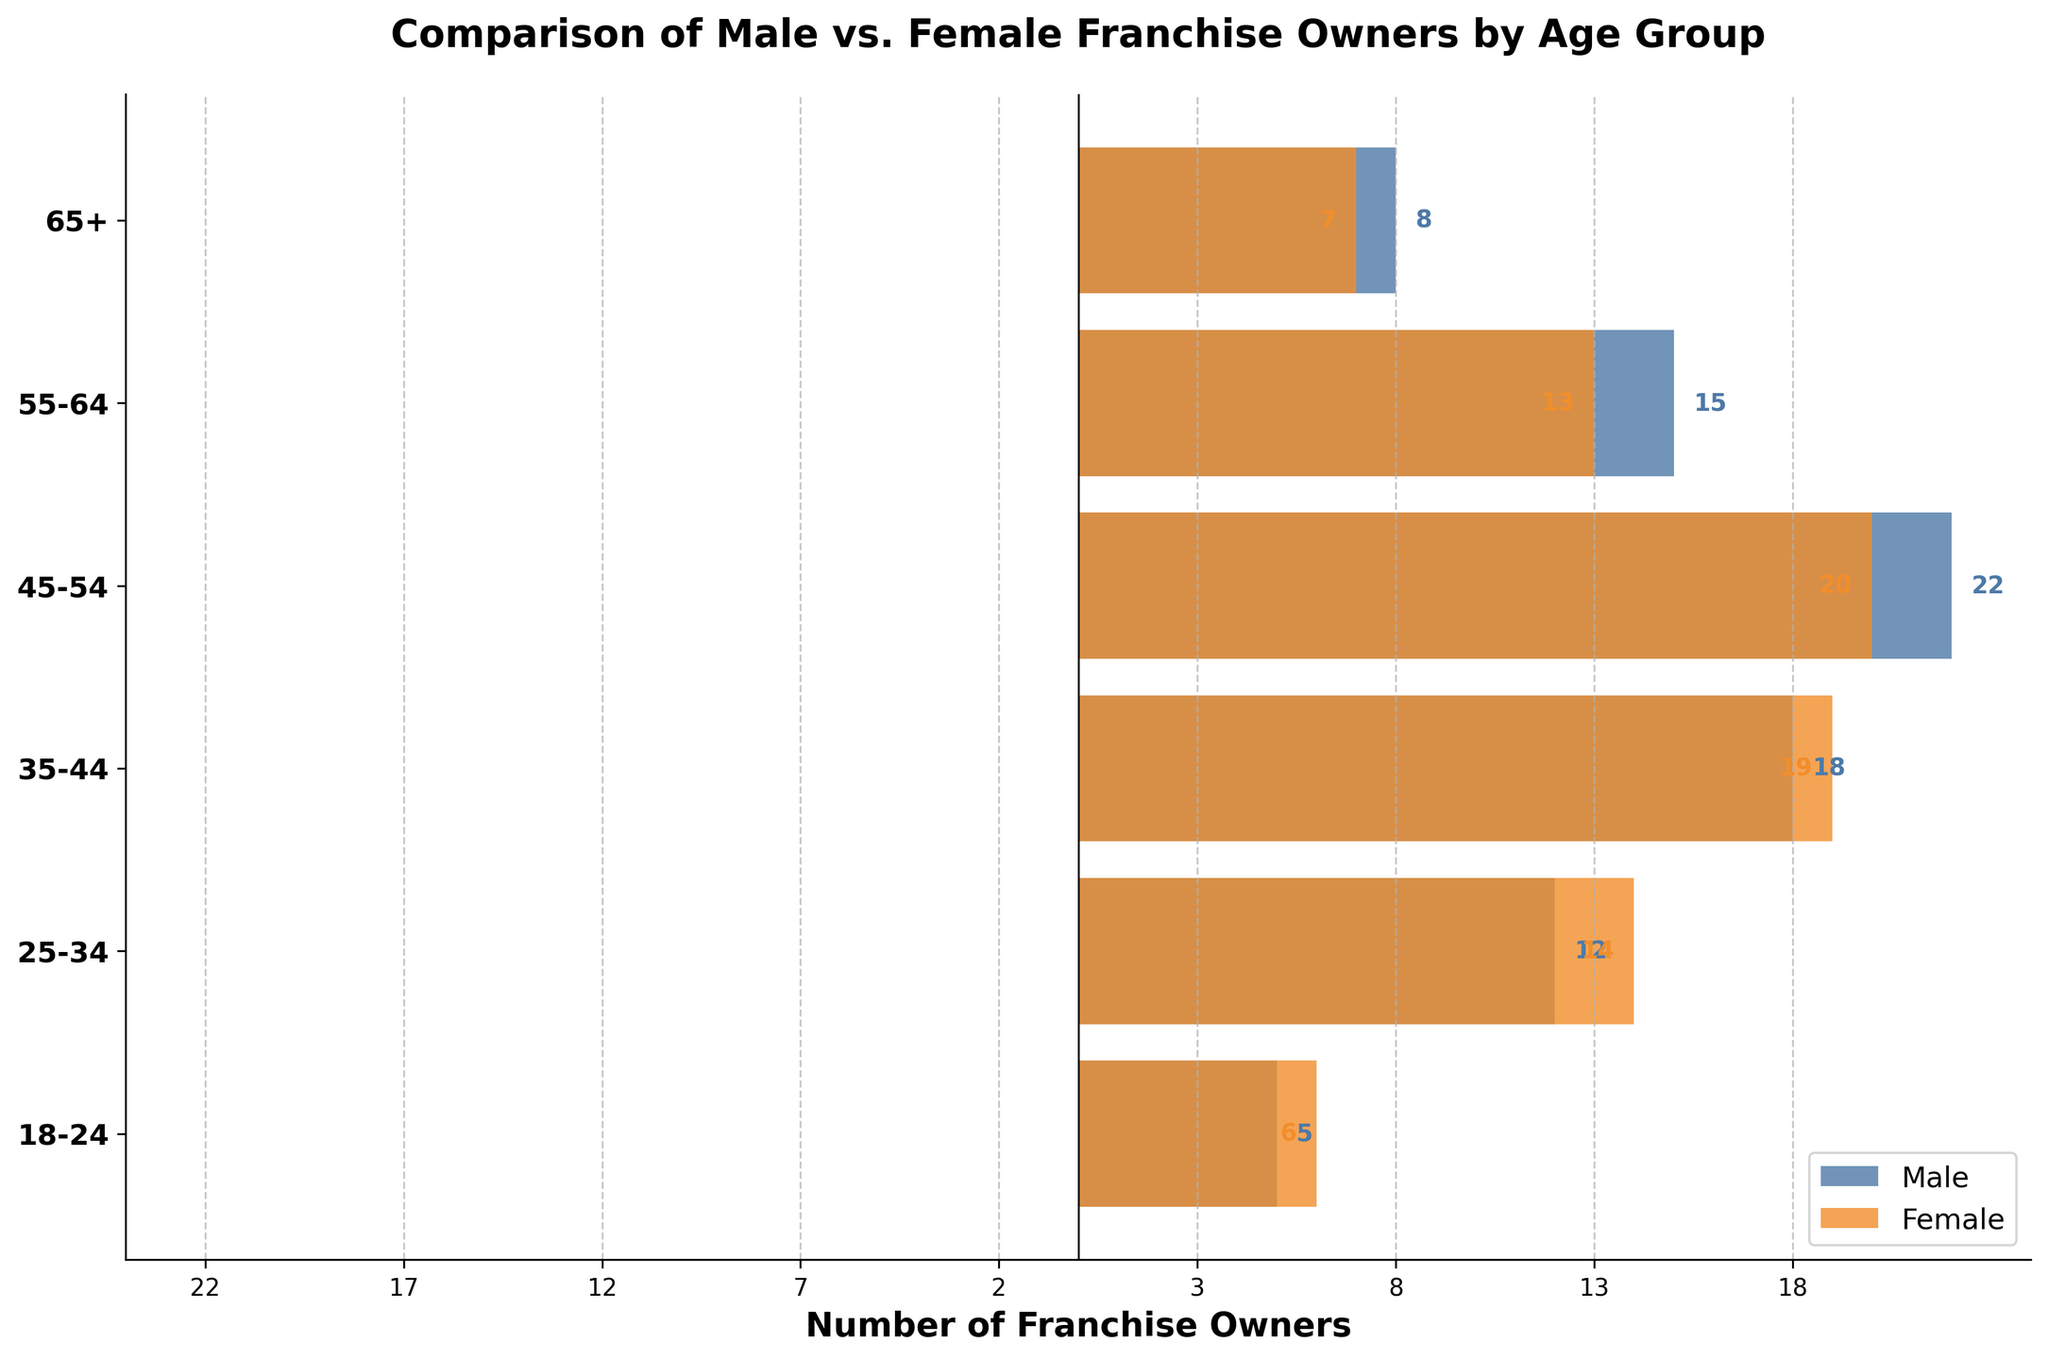What is the title of the figure? The title is located at the top of the figure and summarizes what the figure is about. The title reads "Comparison of Male vs. Female Franchise Owners by Age Group."
Answer: Comparison of Male vs. Female Franchise Owners by Age Group How many age groups are represented in the figure? The y-axis of the figure lists all the age groups included in the study. Counting them, we find six age groups: "65+", "55-64", "45-54", "35-44", "25-34", and "18-24".
Answer: 6 Which age group has the highest number of male franchise owners? We observe the length of the blue bars (representing male franchise owners) for each age group. The longest blue bar corresponds to the "45-54" age group.
Answer: 45-54 What is the difference in the number of male and female franchise owners in the 35-44 age group? The blue bar for males in the 35-44 age group indicates 18, and the orange bar for females (negatively represented) indicates 19. The difference is 19 - 18.
Answer: 1 In which age group is there a higher number of female franchise owners compared to males? We need to identify the age group where the orange bar (female franchise owners) is longer than the blue bar. The "35-44" age group has more females (19) than males (18).
Answer: 35-44 What is the sum of male franchise owners in the 25-34 and 18-24 age groups? We add the values of the male franchise owners for these age groups. For 25-34, there are 12 male owners, and for 18-24, there are 5 male owners. The sum is 12 + 5.
Answer: 17 What is the average number of female franchise owners across all age groups? Calculate the sum of female franchise owners across all age groups and divide by the number of age groups. The values are 7, 13, 20, 19, 14, and 6, with a total of 79. The average is 79 / 6.
Answer: 13.17 Which age group has the smallest difference between the number of male and female franchise owners? Calculate the absolute difference between the male and female numbers for each age group: 1 for 65+, 2 for 55-64, 2 for 45-54, 1 for 35-44, 2 for 25-34, and 1 for 18-24. The smallest differences are all 1, occurring in the 65+, 35-44, and 18-24 age groups.
Answer: 65+, 35-44, 18-24 Which age group demonstrates an equal number of male and female franchise owners? Check for the age group where the lengths of the blue and orange bars are equal. There isn't any such age group; no bars have equal lengths for both males and females.
Answer: None How does the total number of franchise owners in the "55-64" age group compare to those in the "65+" age group? Sum the franchise owners in each age group: for 55-64, it's 15 (male) + 13 (female) = 28; for 65+, it's 8 (male) + 7 (female) = 15. The "55-64" age group has 13 more franchise owners than the "65+" age group.
Answer: 13 more 